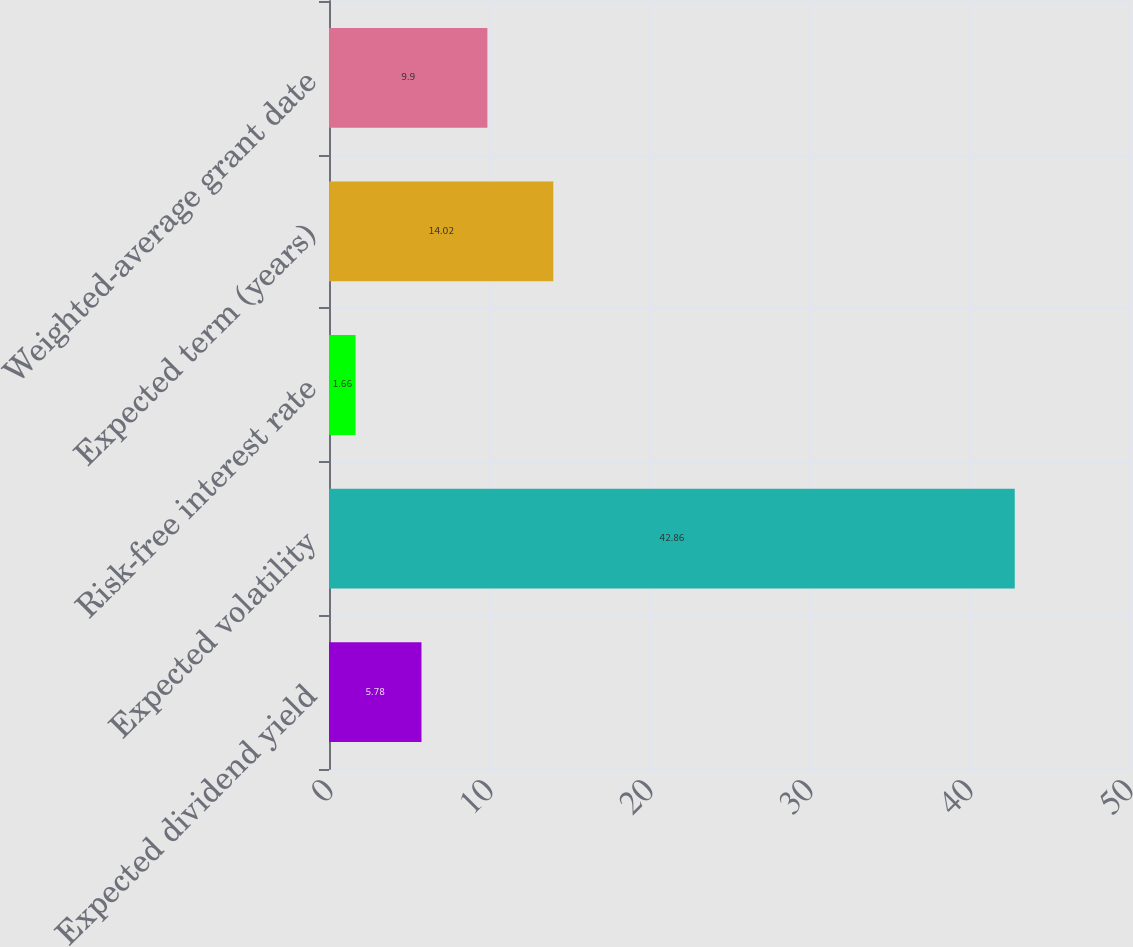<chart> <loc_0><loc_0><loc_500><loc_500><bar_chart><fcel>Expected dividend yield<fcel>Expected volatility<fcel>Risk-free interest rate<fcel>Expected term (years)<fcel>Weighted-average grant date<nl><fcel>5.78<fcel>42.86<fcel>1.66<fcel>14.02<fcel>9.9<nl></chart> 